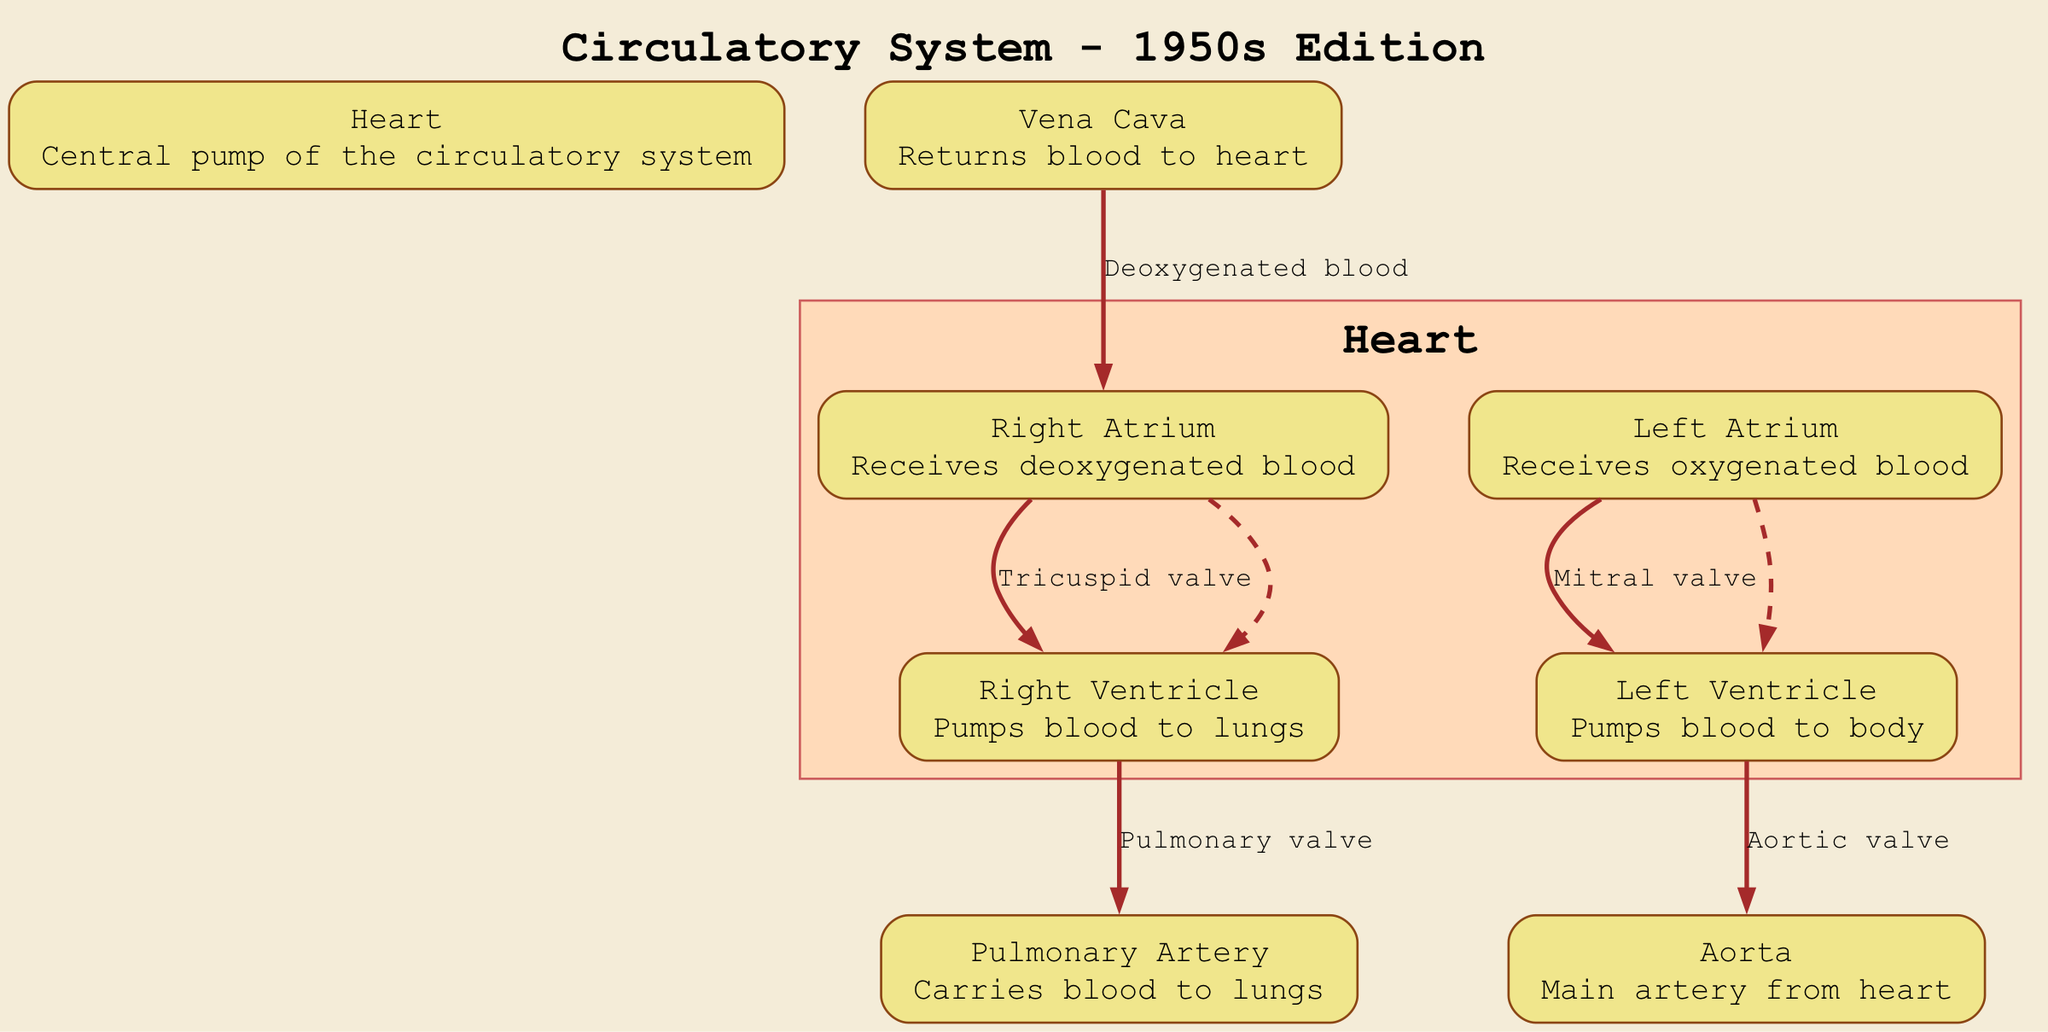What is the central pump of the circulatory system? The diagram clearly labels the heart as the central pump of the circulatory system.
Answer: Heart Which chamber of the heart receives deoxygenated blood? The diagram indicates that the right atrium receives deoxygenated blood.
Answer: Right Atrium How many major blood vessels are highlighted in the diagram? The nodes representing blood vessels include the aorta, pulmonary artery, and vena cava, totaling three major blood vessels highlighted in the diagram.
Answer: 3 What valve is located between the right atrium and right ventricle? The diagram specifies that the tricuspid valve is present between the right atrium and right ventricle.
Answer: Tricuspid valve What direction does blood flow from the left ventricle? According to the diagram, blood flows from the left ventricle into the aorta, indicating the movement of oxygenated blood to the body.
Answer: To the body Where does the vena cava return blood? The diagram shows that the vena cava returns blood to the heart, specifically to the right atrium.
Answer: To the heart What is the function of the pulmonary artery? The description for the pulmonary artery in the diagram states it carries blood to the lungs for oxygenation.
Answer: Carries blood to lungs Which valve is located between the left atrium and left ventricle? The diagram identifies the mitral valve as the valve situated between the left atrium and left ventricle.
Answer: Mitral valve What type of blood does the left atrium receive? The diagram indicates that the left atrium receives oxygenated blood from the lungs.
Answer: Oxygenated blood 